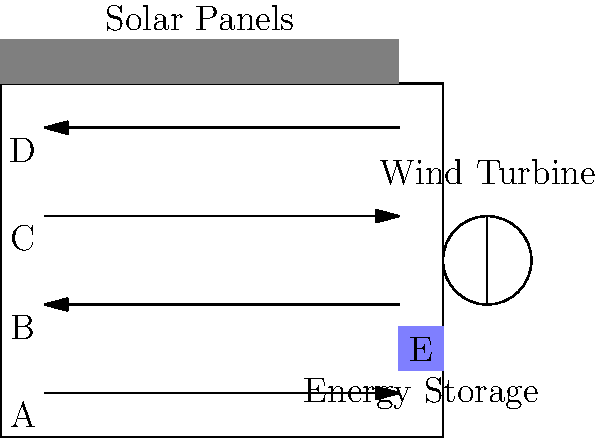In the diagram above, an auto manufacturing plant layout is shown with integrated renewable energy sources. The assembly line is represented by arrows, and there are four production stages labeled A, B, C, and D. Solar panels are installed on the roof, and a wind turbine is located outside. Energy storage is represented by area E. 

Which sequence of production stages would maximize energy efficiency, assuming that stages closer to the energy storage (E) consume less energy due to reduced transmission losses? To determine the most energy-efficient sequence of production stages, we need to consider their proximity to the energy storage unit (E). The closer a stage is to E, the less energy will be lost in transmission.

Let's analyze the distances of each stage from E:

1. Stage D is the closest to E, as it's on the same level and directly adjacent.
2. Stage C is the second closest, being one level below D.
3. Stage B is the third closest, two levels below D.
4. Stage A is the farthest, three levels below D.

To maximize energy efficiency, we should arrange the production stages in order of energy consumption, with the highest consuming stages closest to E. This means we should sequence the stages from the closest to the farthest from E.

Therefore, the most energy-efficient sequence would be:

D → C → B → A

This arrangement ensures that the stages with potentially higher energy requirements are closer to the energy storage, minimizing transmission losses and maximizing overall energy efficiency in the production line.
Answer: D → C → B → A 